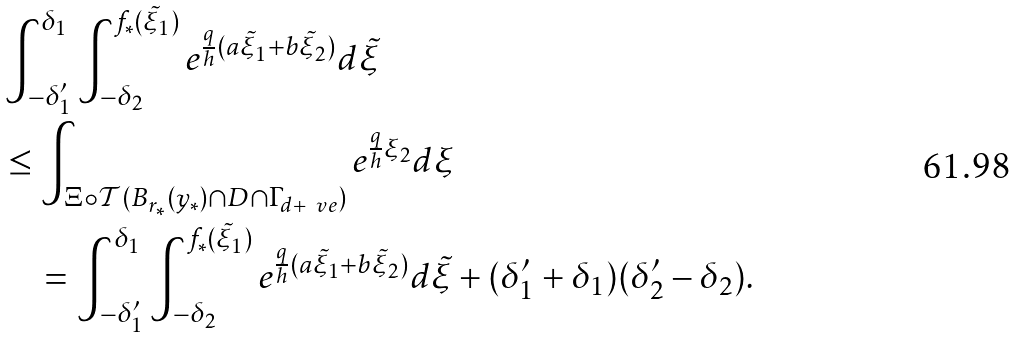Convert formula to latex. <formula><loc_0><loc_0><loc_500><loc_500>& \int _ { - \delta _ { 1 } ^ { \prime } } ^ { \delta _ { 1 } } \int _ { - \delta _ { 2 } } ^ { f _ { * } ( \tilde { \xi } _ { 1 } ) } e ^ { \frac { q } { h } ( a \tilde { \xi } _ { 1 } + b \tilde { \xi } _ { 2 } ) } d \tilde { \xi } \\ & \leq \int _ { \Xi \circ \mathcal { T } ( B _ { r _ { * } } ( y _ { * } ) \cap D \cap \Gamma _ { d + \ v e } ) } e ^ { \frac { q } { h } \xi _ { 2 } } d \xi \\ & \quad = \int _ { - \delta _ { 1 } ^ { \prime } } ^ { \delta _ { 1 } } \int _ { - \delta _ { 2 } } ^ { f _ { * } ( \tilde { \xi } _ { 1 } ) } e ^ { \frac { q } { h } ( a \tilde { \xi } _ { 1 } + b \tilde { \xi } _ { 2 } ) } d \tilde { \xi } + ( \delta _ { 1 } ^ { \prime } + \delta _ { 1 } ) ( \delta _ { 2 } ^ { \prime } - \delta _ { 2 } ) .</formula> 